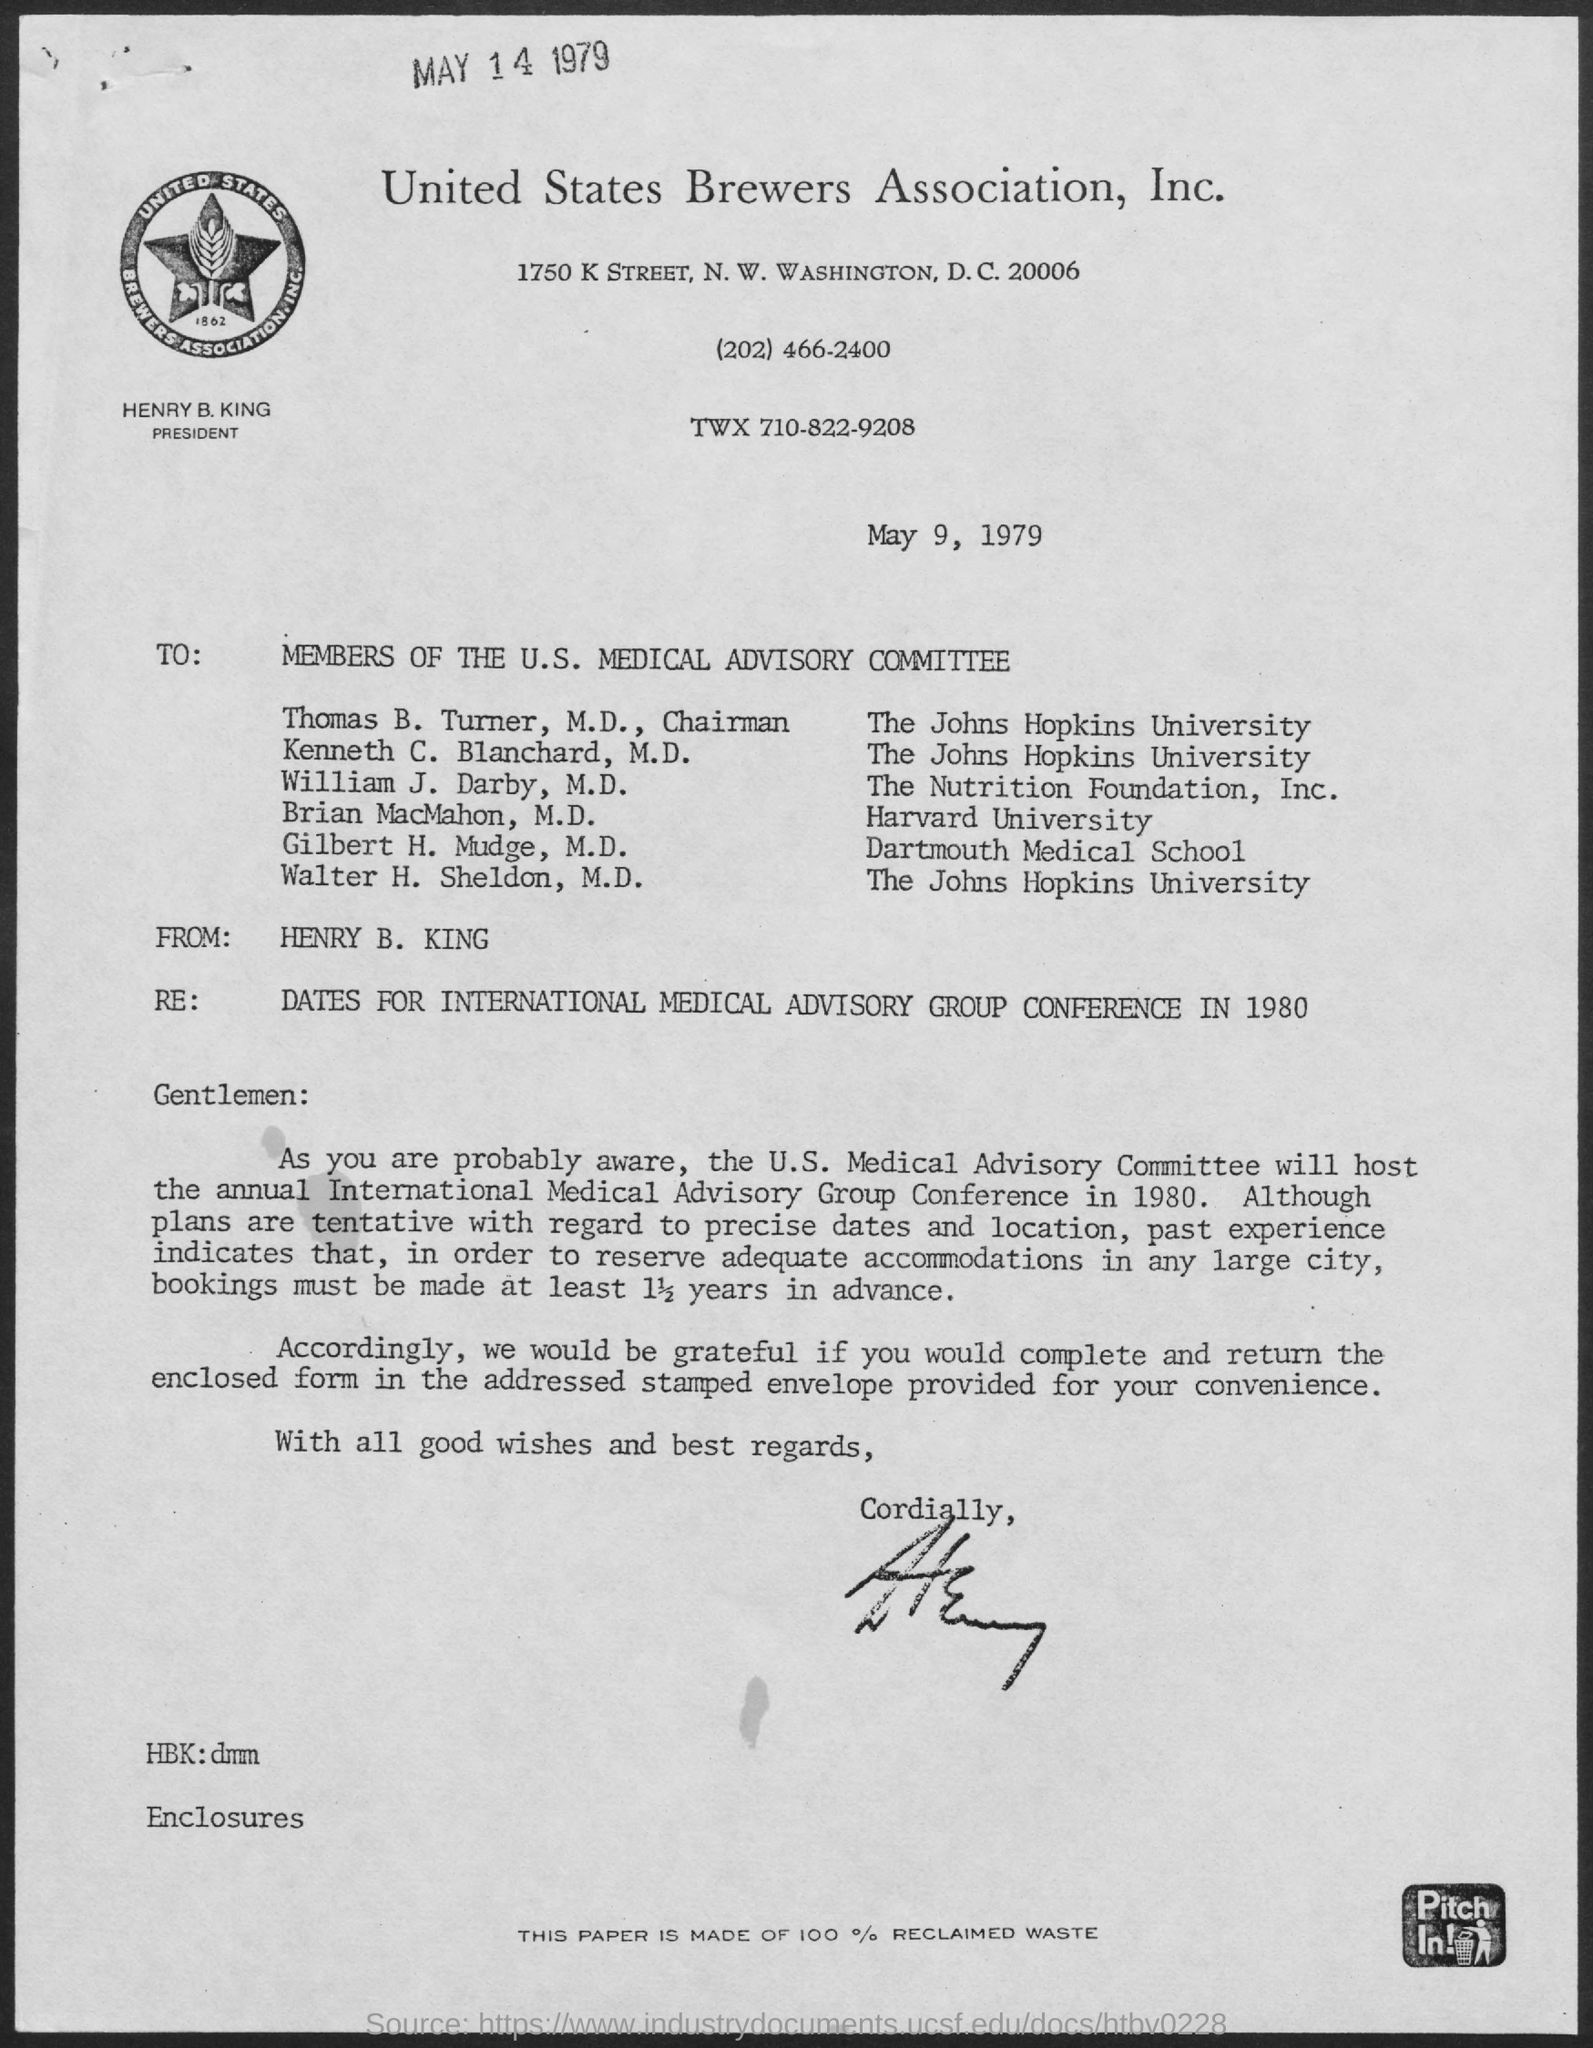What is the name of the association mentioned ?
Provide a short and direct response. United states brewers association, inc. What is the date mentioned ?
Provide a succinct answer. May 9, 1979. To whom the letter was written ?
Give a very brief answer. Members of the u.s. medical advisory committee. From whom the letter was received ?
Your answer should be compact. HENRY B. KING. What is the date mentioned at the top of the page ?
Keep it short and to the point. MAY 14 1979. 